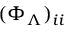Convert formula to latex. <formula><loc_0><loc_0><loc_500><loc_500>( \Phi _ { \Lambda } ) _ { i i }</formula> 